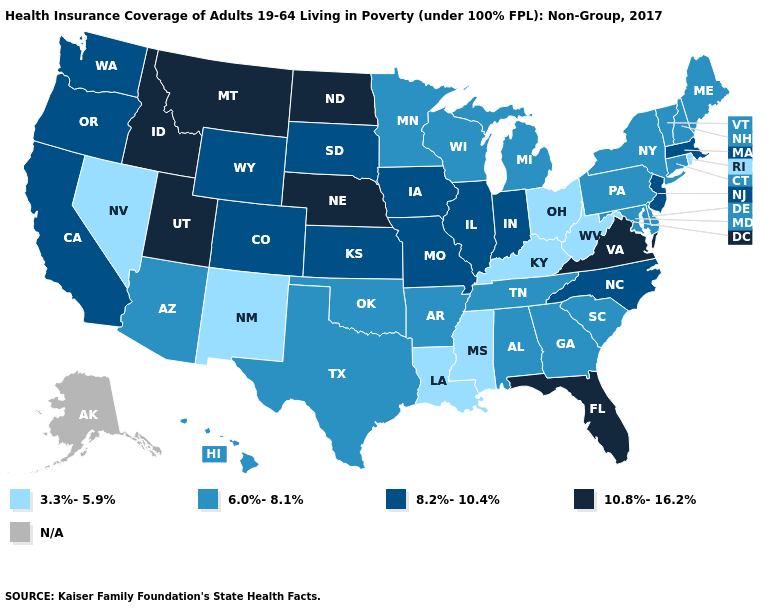Does the first symbol in the legend represent the smallest category?
Keep it brief. Yes. Name the states that have a value in the range 10.8%-16.2%?
Concise answer only. Florida, Idaho, Montana, Nebraska, North Dakota, Utah, Virginia. Does Louisiana have the lowest value in the USA?
Short answer required. Yes. Is the legend a continuous bar?
Be succinct. No. What is the value of Arizona?
Answer briefly. 6.0%-8.1%. Name the states that have a value in the range 10.8%-16.2%?
Give a very brief answer. Florida, Idaho, Montana, Nebraska, North Dakota, Utah, Virginia. Name the states that have a value in the range 10.8%-16.2%?
Answer briefly. Florida, Idaho, Montana, Nebraska, North Dakota, Utah, Virginia. How many symbols are there in the legend?
Quick response, please. 5. What is the value of Minnesota?
Quick response, please. 6.0%-8.1%. What is the highest value in states that border North Carolina?
Answer briefly. 10.8%-16.2%. Which states hav the highest value in the Northeast?
Quick response, please. Massachusetts, New Jersey. Is the legend a continuous bar?
Quick response, please. No. Name the states that have a value in the range 6.0%-8.1%?
Answer briefly. Alabama, Arizona, Arkansas, Connecticut, Delaware, Georgia, Hawaii, Maine, Maryland, Michigan, Minnesota, New Hampshire, New York, Oklahoma, Pennsylvania, South Carolina, Tennessee, Texas, Vermont, Wisconsin. What is the highest value in the South ?
Short answer required. 10.8%-16.2%. 